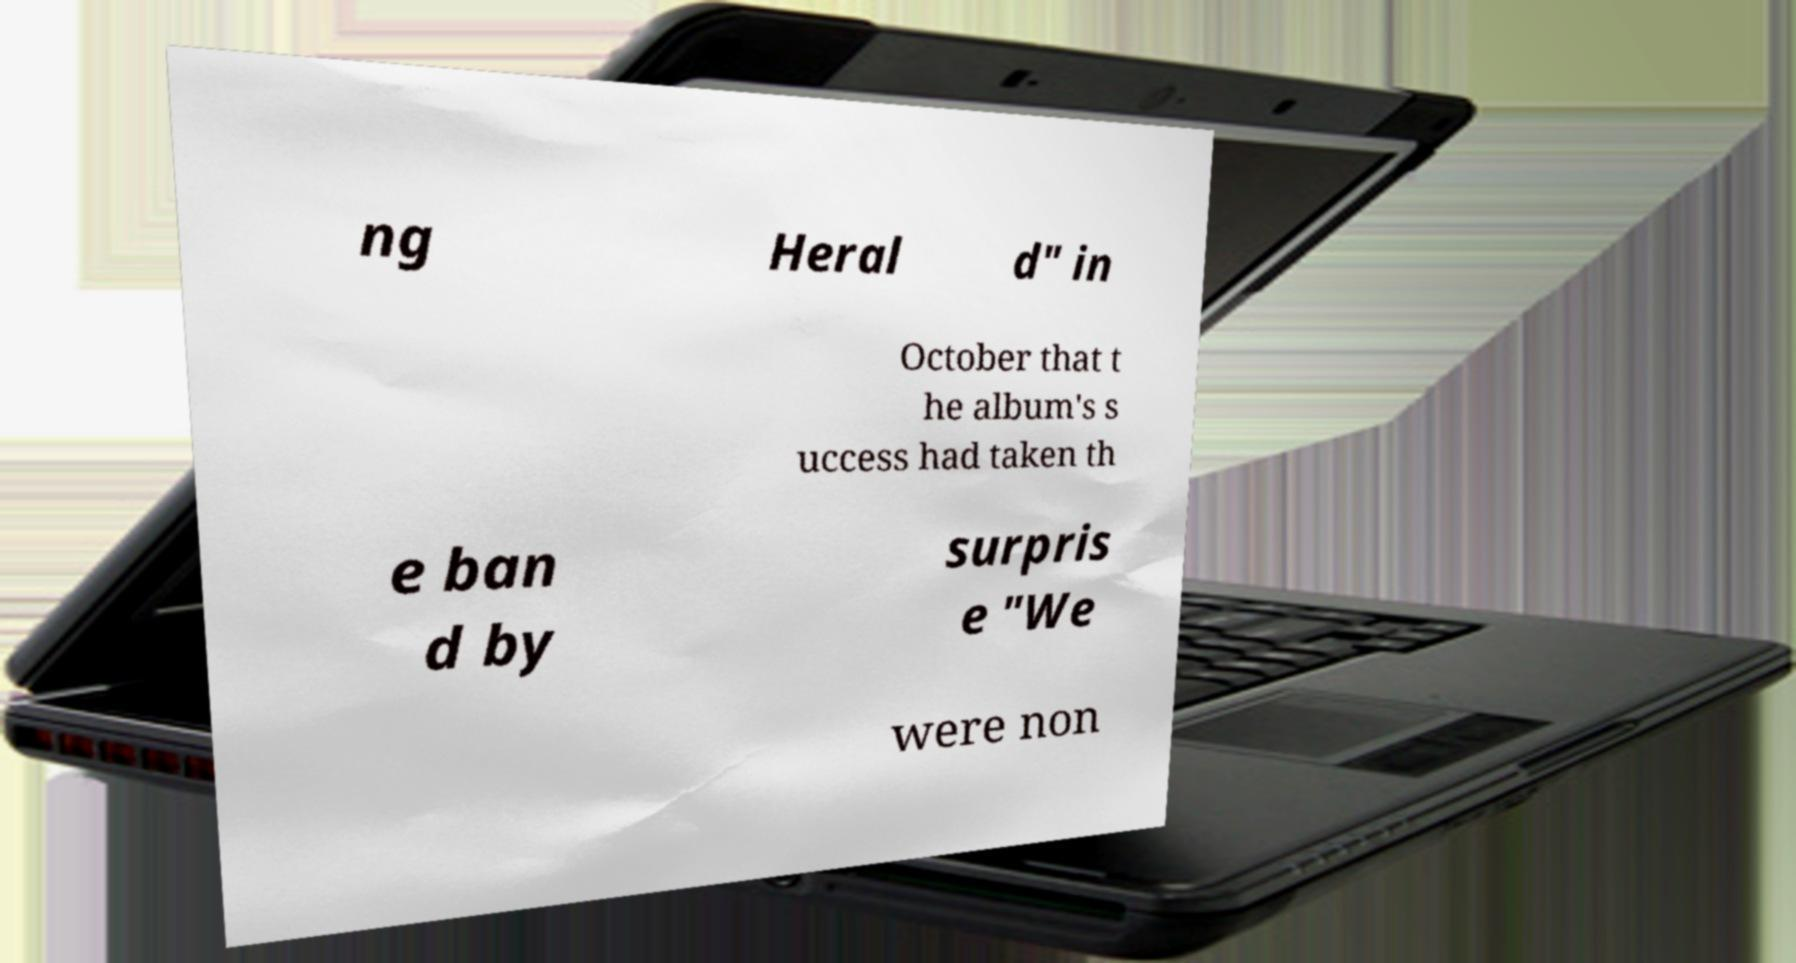Please identify and transcribe the text found in this image. ng Heral d" in October that t he album's s uccess had taken th e ban d by surpris e "We were non 